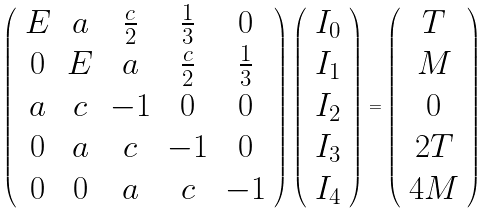Convert formula to latex. <formula><loc_0><loc_0><loc_500><loc_500>\left ( \begin{array} { c c c c c } E & a & \frac { c } { 2 } & \frac { 1 } { 3 } & 0 \\ 0 & E & a & \frac { c } { 2 } & \frac { 1 } { 3 } \\ a & c & - 1 & 0 & 0 \\ 0 & a & c & - 1 & 0 \\ 0 & 0 & a & c & - 1 \end{array} \right ) \left ( \begin{array} { c } I _ { 0 } \\ I _ { 1 } \\ I _ { 2 } \\ I _ { 3 } \\ I _ { 4 } \end{array} \right ) = \left ( \begin{array} { c } T \\ M \\ 0 \\ 2 T \\ 4 M \end{array} \right )</formula> 